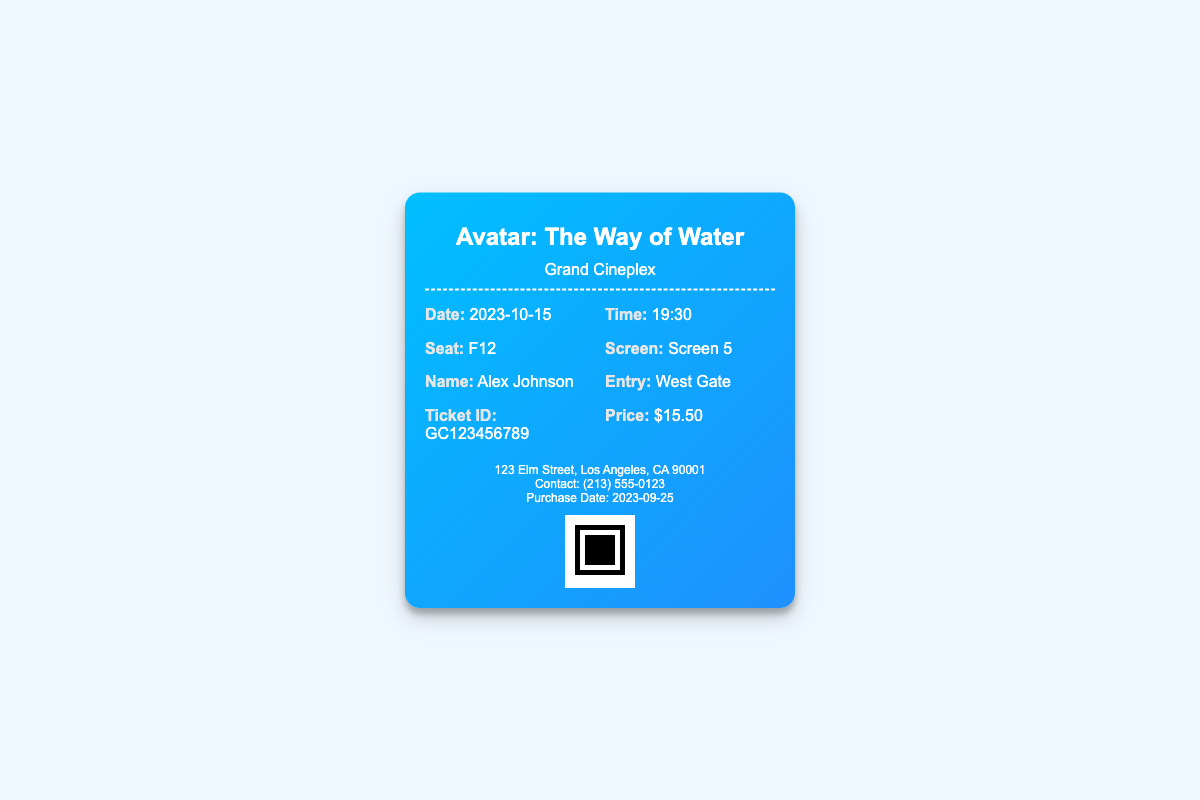What is the title of the movie? The title of the movie is clearly stated at the top of the ticket.
Answer: Avatar: The Way of Water What is the date of the screening? The date can be found in the ticket details section.
Answer: 2023-10-15 What time does the movie start? The start time is provided alongside the date in the ticket info.
Answer: 19:30 What is the seat number for the ticket? The seat number is listed in the ticket information.
Answer: F12 Who is the ticket holder? The ticket holder's name is displayed in the details on the ticket.
Answer: Alex Johnson What is the price of the ticket? The price is indicated in the ticket information section.
Answer: $15.50 What is the entry point for the screening? The entry point is mentioned in the ticket details.
Answer: West Gate Which screen is the movie being shown on? The screen number is specified in the ticket info section.
Answer: Screen 5 What was the purchase date of the ticket? The purchase date is noted in the footer of the ticket.
Answer: 2023-09-25 